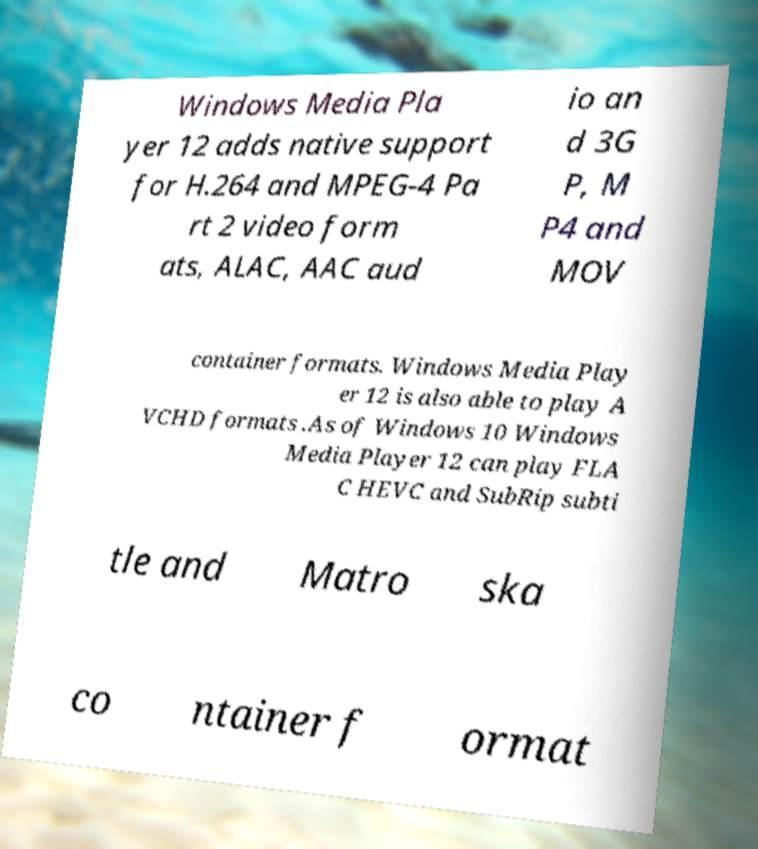Please identify and transcribe the text found in this image. Windows Media Pla yer 12 adds native support for H.264 and MPEG-4 Pa rt 2 video form ats, ALAC, AAC aud io an d 3G P, M P4 and MOV container formats. Windows Media Play er 12 is also able to play A VCHD formats .As of Windows 10 Windows Media Player 12 can play FLA C HEVC and SubRip subti tle and Matro ska co ntainer f ormat 